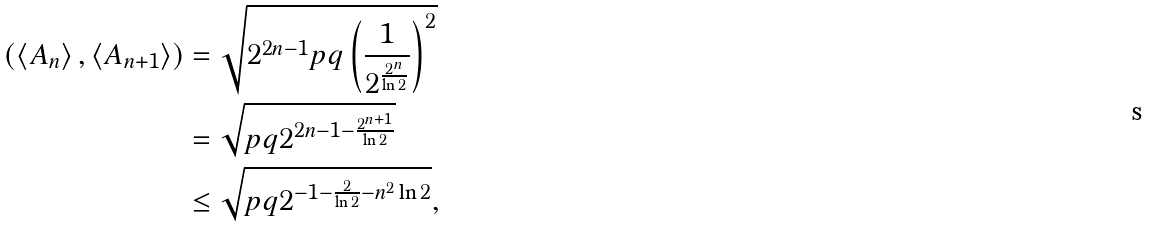<formula> <loc_0><loc_0><loc_500><loc_500>( \left < A _ { n } \right > , \left < A _ { n + 1 } \right > ) & = \sqrt { 2 ^ { 2 n - 1 } p q \left ( \frac { 1 } { 2 ^ { \frac { 2 ^ { n } } { \ln 2 } } } \right ) ^ { 2 } } \\ & = \sqrt { p q 2 ^ { 2 n - 1 - \frac { 2 ^ { n + 1 } } { \ln 2 } } } \\ & \leq \sqrt { p q 2 ^ { - 1 - \frac { 2 } { \ln 2 } - n ^ { 2 } \ln 2 } } ,</formula> 